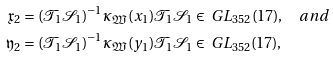Convert formula to latex. <formula><loc_0><loc_0><loc_500><loc_500>\mathfrak { x } _ { 2 } & = ( \mathcal { T } _ { 1 } \mathcal { S } _ { 1 } ) ^ { - 1 } \kappa _ { \mathfrak { W } } ( x _ { 1 } ) \mathcal { T } _ { 1 } \mathcal { S } _ { 1 } \in \ G L _ { 3 5 2 } ( 1 7 ) , \quad a n d \\ \mathfrak { y } _ { 2 } & = ( \mathcal { T } _ { 1 } \mathcal { S } _ { 1 } ) ^ { - 1 } \kappa _ { \mathfrak { W } } ( y _ { 1 } ) \mathcal { T } _ { 1 } \mathcal { S } _ { 1 } \in \ G L _ { 3 5 2 } ( 1 7 ) ,</formula> 